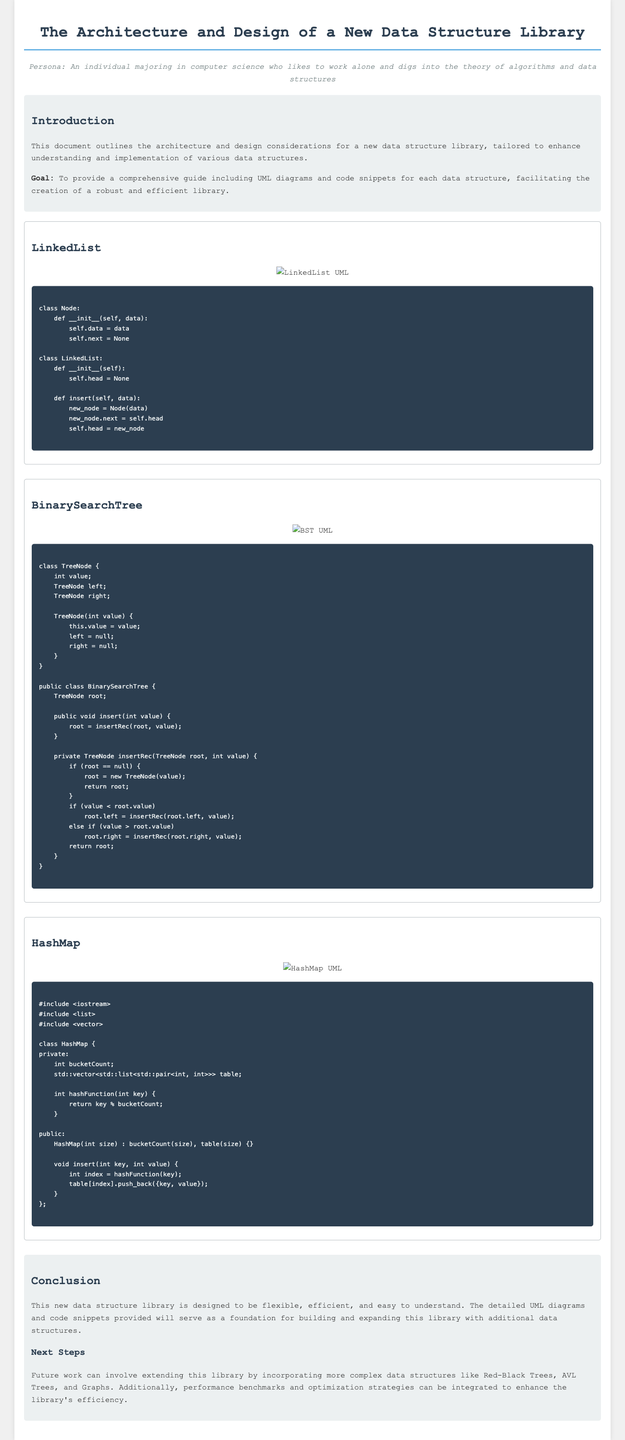What is the title of the document? The title is displayed prominently at the top of the document.
Answer: The Architecture and Design of a New Data Structure Library What programming language is used for the LinkedList code snippet? The code snippet for LinkedList is provided in a specific programming language.
Answer: Python Which data structure has the UML diagram with the link "https://example.com/bst_uml.png"? The link refers to the UML diagram included for a certain data structure.
Answer: BinarySearchTree What is the primary goal of the document? The goal is mentioned in the introduction section of the document.
Answer: To provide a comprehensive guide How many data structures are discussed in the document? The number of distinct data structures described in the document is a key detail.
Answer: Three What does the HashMap class use to store values? The storage mechanism used in the HashMap class is highlighted within its description.
Answer: List What was suggested for future work in the conclusion? The conclusion section projects enhancements for the library through various suggestions.
Answer: More complex data structures What style is used for the introduction and conclusion sections? These sections have a specific background color and padding styles applied to them.
Answer: Light gray background In which section can you find the UML diagrams? The UML diagrams are embedded within a specific section associated with each data structure.
Answer: In each data structure section 